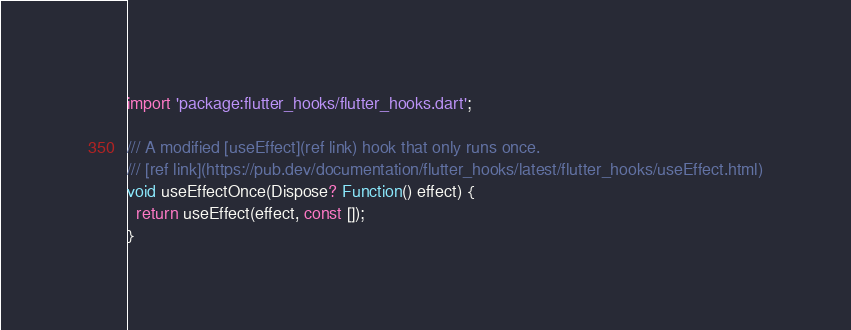Convert code to text. <code><loc_0><loc_0><loc_500><loc_500><_Dart_>import 'package:flutter_hooks/flutter_hooks.dart';

/// A modified [useEffect](ref link) hook that only runs once.
/// [ref link](https://pub.dev/documentation/flutter_hooks/latest/flutter_hooks/useEffect.html)
void useEffectOnce(Dispose? Function() effect) {
  return useEffect(effect, const []);
}
</code> 